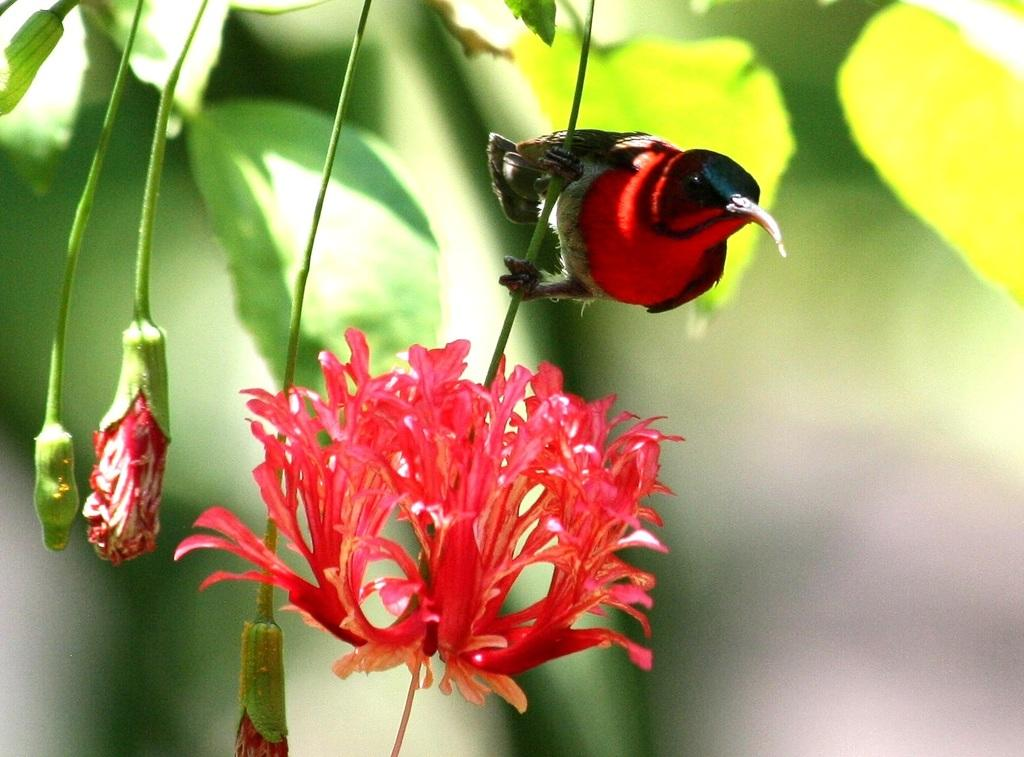What type of flowers can be seen in the image? There are red flowers in the image. Can you describe the background of the image? The background of the image is blurred. Are there any giants visible in the image? There are no giants present in the image. What type of plant is growing in the crib in the image? There is no crib or plant growing in a crib present in the image. 